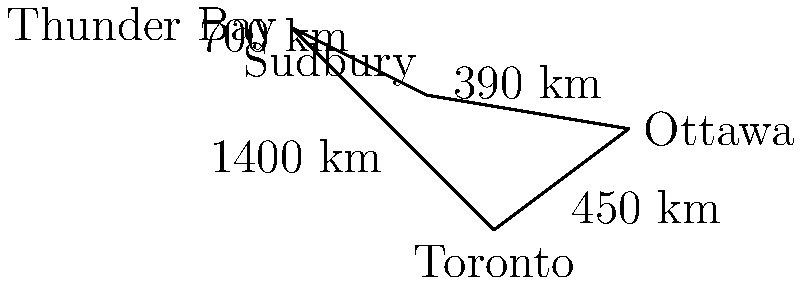As a long-haul truck driver, you need to deliver goods to all four cities shown on the map: Toronto, Ottawa, Sudbury, and Thunder Bay. What is the shortest possible route that visits all cities exactly once and returns to the starting point? Give your answer as the total distance traveled in kilometers. To solve this problem, we need to consider all possible routes and calculate their total distances. This is known as the Traveling Salesman Problem.

There are 3! = 6 possible routes (starting and ending in Toronto):

1. Toronto - Ottawa - Sudbury - Thunder Bay - Toronto
2. Toronto - Ottawa - Thunder Bay - Sudbury - Toronto
3. Toronto - Sudbury - Ottawa - Thunder Bay - Toronto
4. Toronto - Sudbury - Thunder Bay - Ottawa - Toronto
5. Toronto - Thunder Bay - Ottawa - Sudbury - Toronto
6. Toronto - Thunder Bay - Sudbury - Ottawa - Toronto

Let's calculate the distance for each route:

1. $450 + 390 + 700 + 1400 = 2940$ km
2. $450 + (700 + 390) + 1400 = 2940$ km
3. $(450 + 390) + 700 + 1400 = 2940$ km
4. $(450 + 700) + 390 + 1400 = 2940$ km
5. $1400 + (450 + 390) + 700 = 2940$ km
6. $1400 + 700 + (450 + 390) = 2940$ km

Interestingly, all routes have the same total distance of 2940 km. This is because the cities form a complete graph where every city is connected to every other city, and the sum of all edges is constant regardless of the order visited.

Therefore, any route that visits all cities exactly once and returns to the starting point will have the same total distance.
Answer: 2940 km 